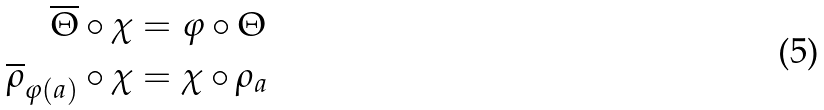Convert formula to latex. <formula><loc_0><loc_0><loc_500><loc_500>\overline { \Theta } \circ \chi & = \varphi \circ \Theta \\ \overline { \rho } _ { \varphi ( a ) } \circ \chi & = \chi \circ \rho _ { a }</formula> 